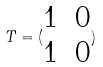Convert formula to latex. <formula><loc_0><loc_0><loc_500><loc_500>T = ( \begin{matrix} 1 & 0 \\ 1 & 0 \end{matrix} )</formula> 